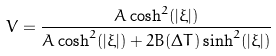<formula> <loc_0><loc_0><loc_500><loc_500>V = \frac { A \cosh ^ { 2 } ( | \xi | ) } { A \cosh ^ { 2 } ( | \xi | ) + 2 B ( \Delta T ) \sinh ^ { 2 } ( | \xi | ) }</formula> 